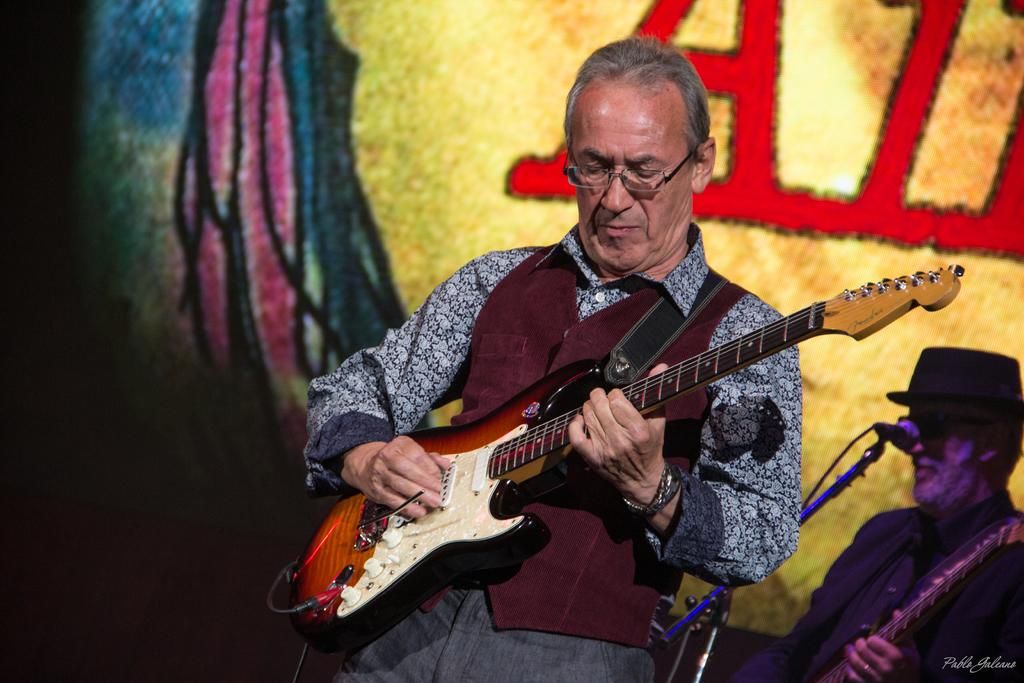How many people are in the image? There are two persons in the image. What are the persons doing in the image? The persons are standing and holding guitars. What object is present for amplifying sound in the image? There is a microphone with a microphone stand in the image. What can be seen in the background of the image? There is a poster in the background of the image. How many clocks are visible on the wall in the image? There are no clocks visible on the wall in the image. What type of religious symbol can be seen on the poster in the image? There is no religious symbol present on the poster in the image. 